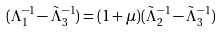<formula> <loc_0><loc_0><loc_500><loc_500>( \Lambda _ { 1 } ^ { - 1 } - \tilde { \Lambda } _ { 3 } ^ { - 1 } ) = ( 1 + \mu ) ( \tilde { \Lambda } _ { 2 } ^ { - 1 } - \tilde { \Lambda } _ { 3 } ^ { - 1 } )</formula> 